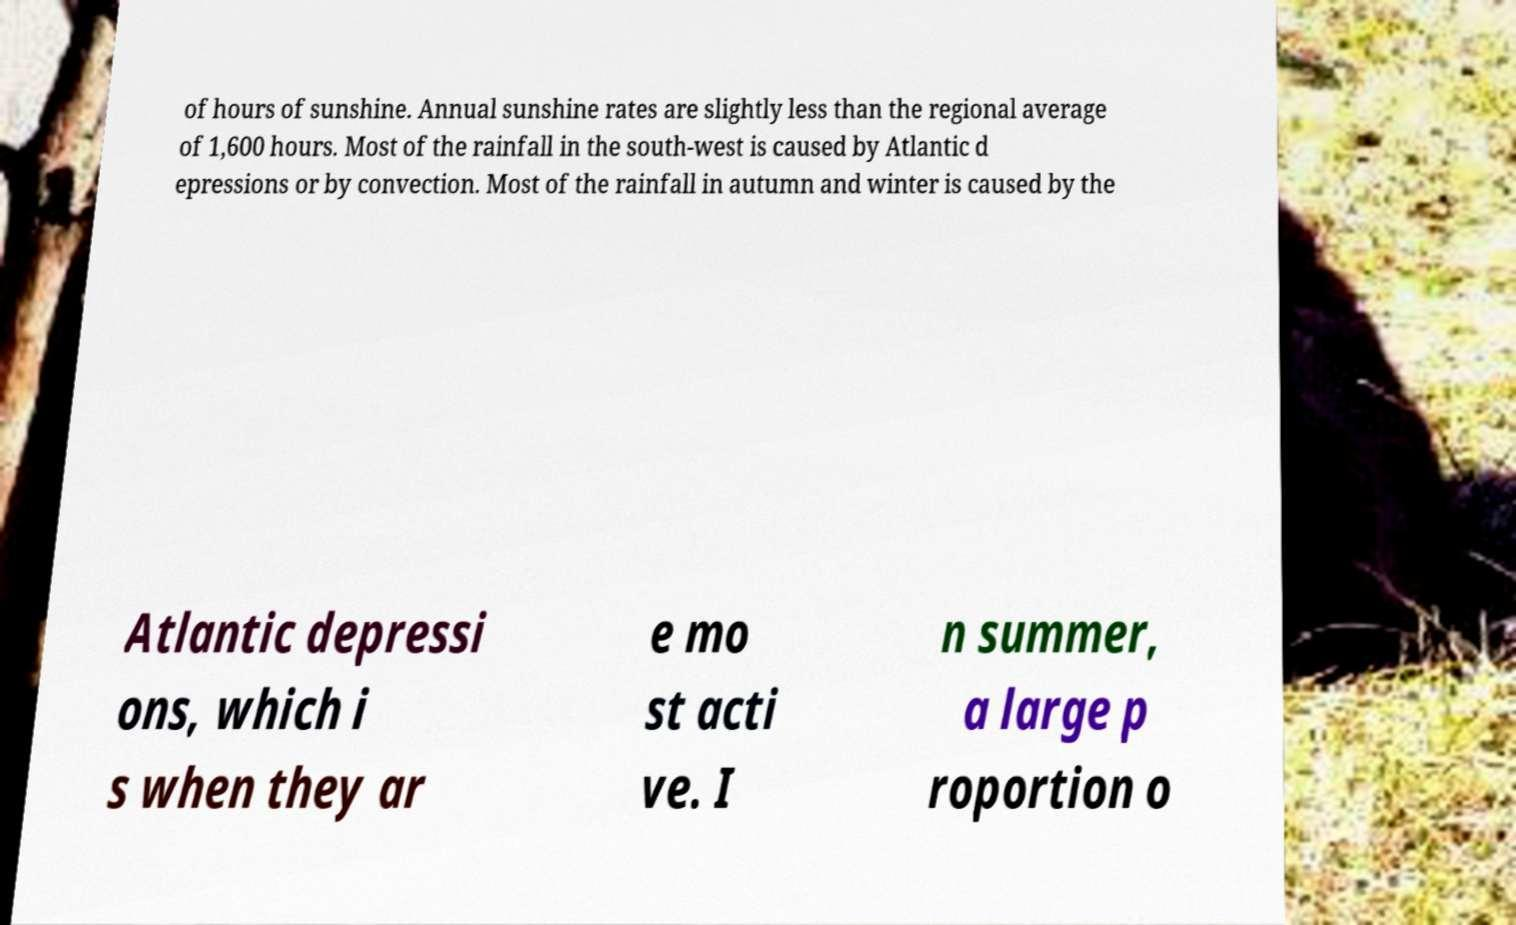For documentation purposes, I need the text within this image transcribed. Could you provide that? of hours of sunshine. Annual sunshine rates are slightly less than the regional average of 1,600 hours. Most of the rainfall in the south-west is caused by Atlantic d epressions or by convection. Most of the rainfall in autumn and winter is caused by the Atlantic depressi ons, which i s when they ar e mo st acti ve. I n summer, a large p roportion o 